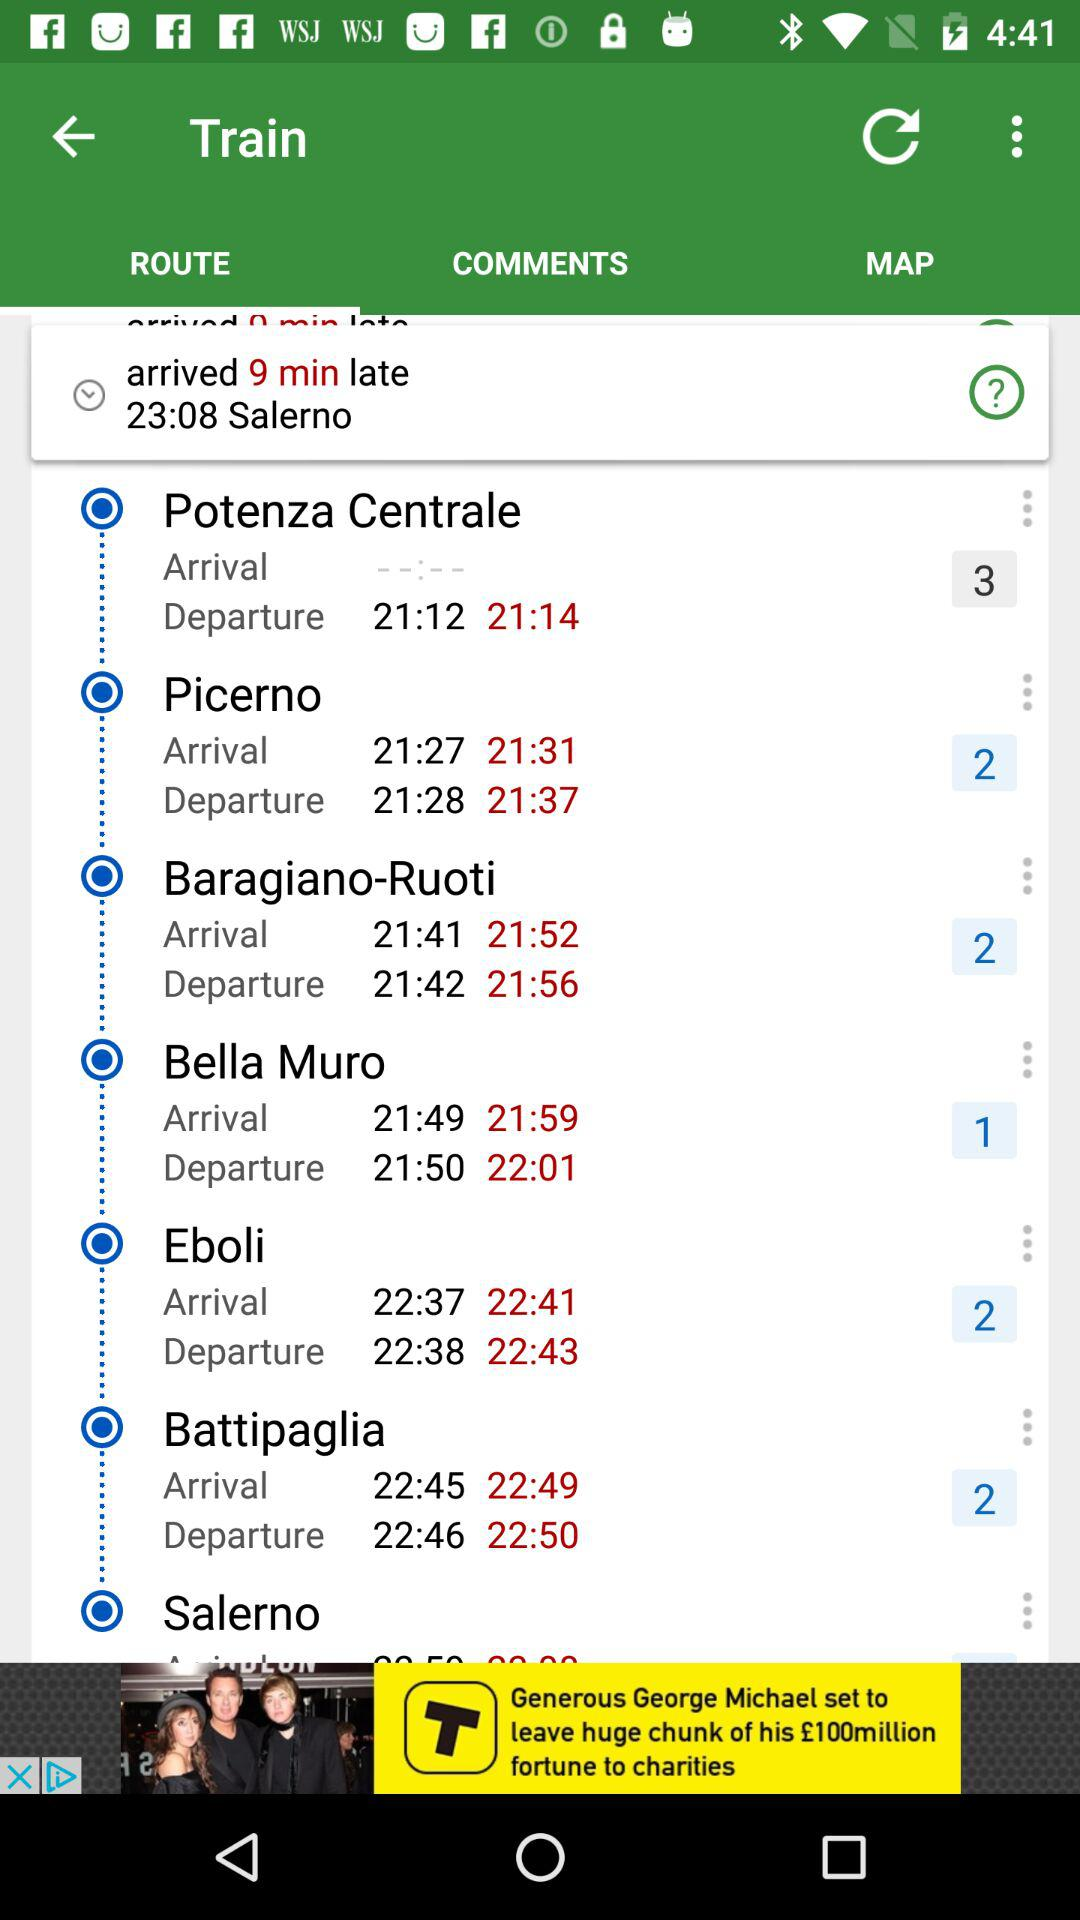What is the actual departure time of the train from "Potenza Centrale"? The actual departure time of the train from "Potenza Centrale" is 21:14. 